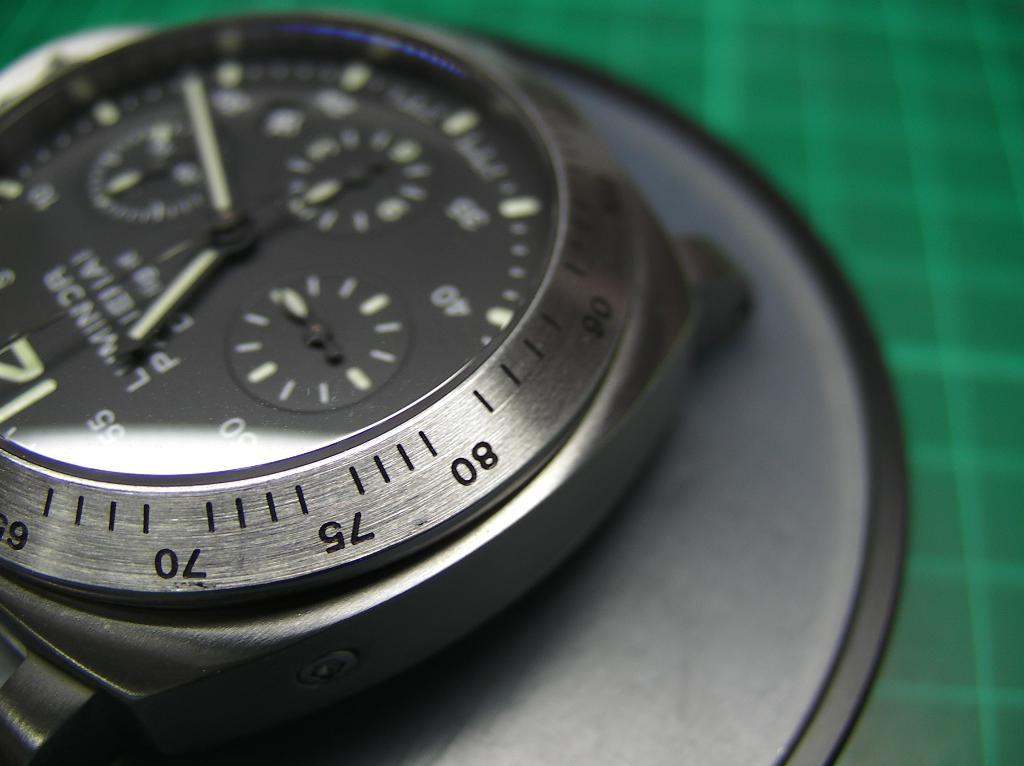<image>
Write a terse but informative summary of the picture. A close up of a watch face features numbers around the outside and is set to 11:18. 